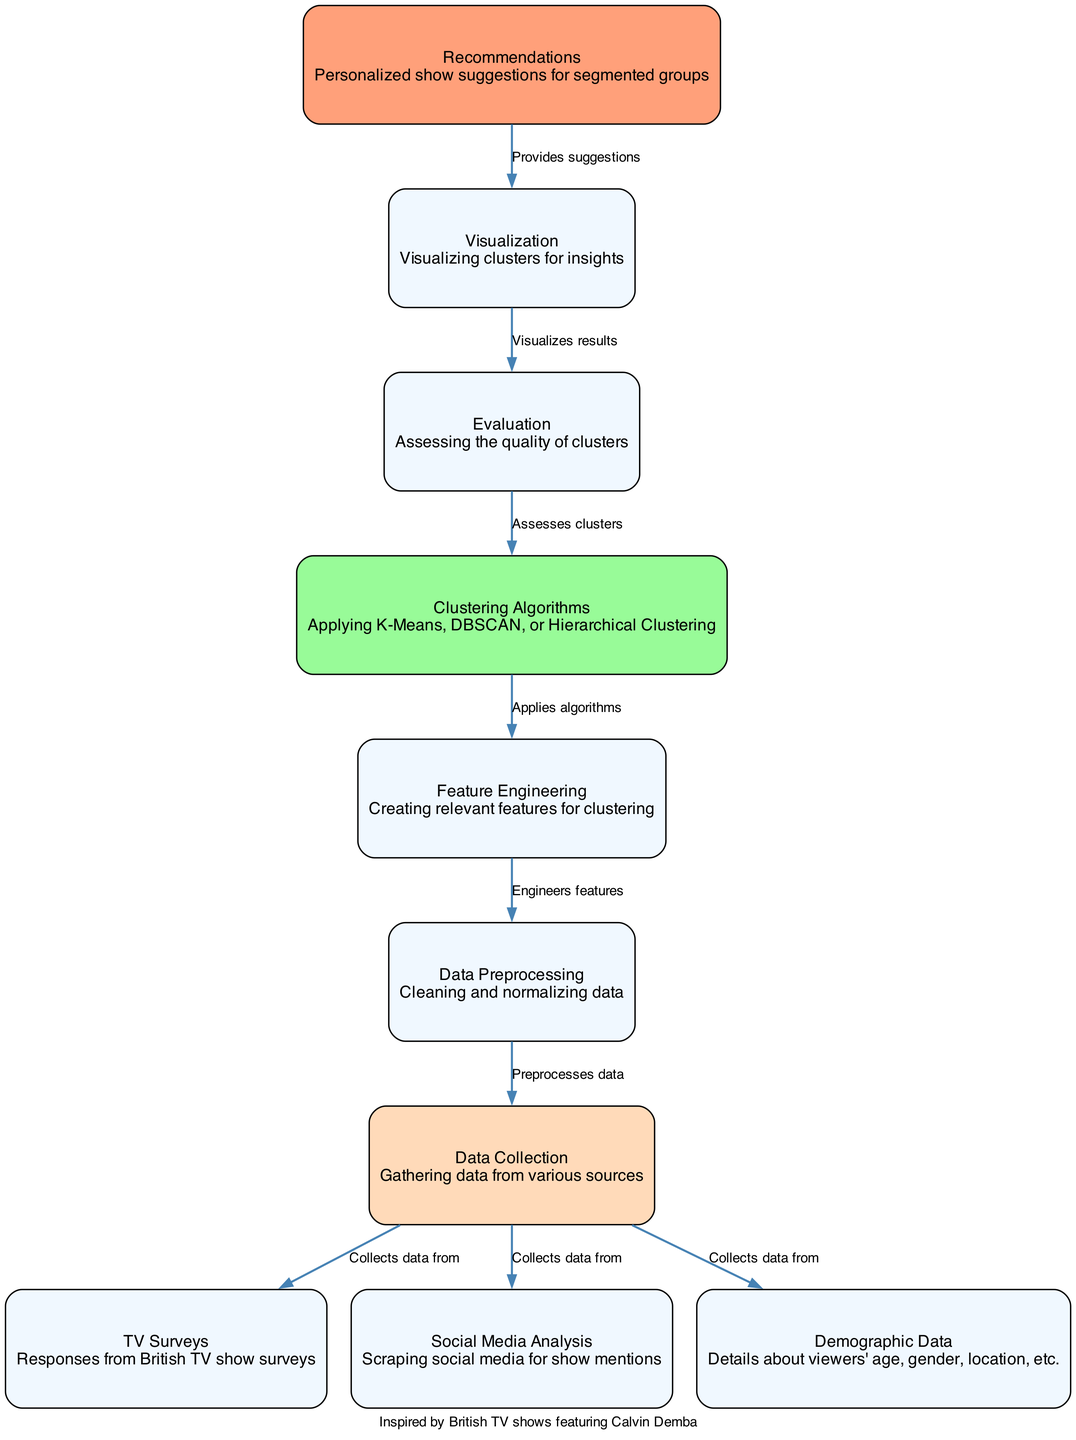What are the data sources for collection? The diagram indicates three sources from which data is collected: TV Surveys, Social Media Analysis, and Demographic Data. These are explicitly shown as nodes that are directly connected to the Data Collection node.
Answer: TV Surveys, Social Media Analysis, Demographic Data Which process follows Data Preprocessing? According to the diagram, after Data Preprocessing, the next step is Feature Engineering, as indicated by the directed edge that leads from Data Preprocessing to Feature Engineering.
Answer: Feature Engineering How many nodes are present in the diagram? The diagram includes ten nodes, which can be counted directly from the node list provided within the diagram's structure.
Answer: Ten What is the relationship between Clustering Algorithms and Feature Engineering? The Clustering Algorithms node applies algorithms to the Feature Engineering node, as represented by the directed edge that connects them. This indicates a dependency where clustering uses the features created in the previous step.
Answer: Applies algorithms What kind of clustering algorithms are mentioned? The specific clustering algorithms mentioned in the diagram include K-Means, DBSCAN, and Hierarchical Clustering, which are noted as part of the description in the Clustering Algorithms node.
Answer: K-Means, DBSCAN, Hierarchical Clustering What component visualizes the results? The Visualization node is responsible for visualizing results according to the diagram, which is highlighted as a critical step that occurs after evaluation.
Answer: Visualization Which node suggests recommendations? Recommendations are provided by the Recommendations node, which is depicted as the final node in the flow where personalized suggestions are made based on the visualized insights.
Answer: Recommendations What step assesses the clusters? The Evaluation step is the one that assesses the quality of the clusters, as shown in the direct connection from the Evaluation node to the Clustering Algorithms node of the diagram.
Answer: Evaluation How does Feature Engineering relate to Data Preprocessing? Feature Engineering engineers features based on the data that has been preprocessed. This is indicated by the directed edge leading from Data Preprocessing to Feature Engineering, showing that the latter is contingent upon the former.
Answer: Engineers features 